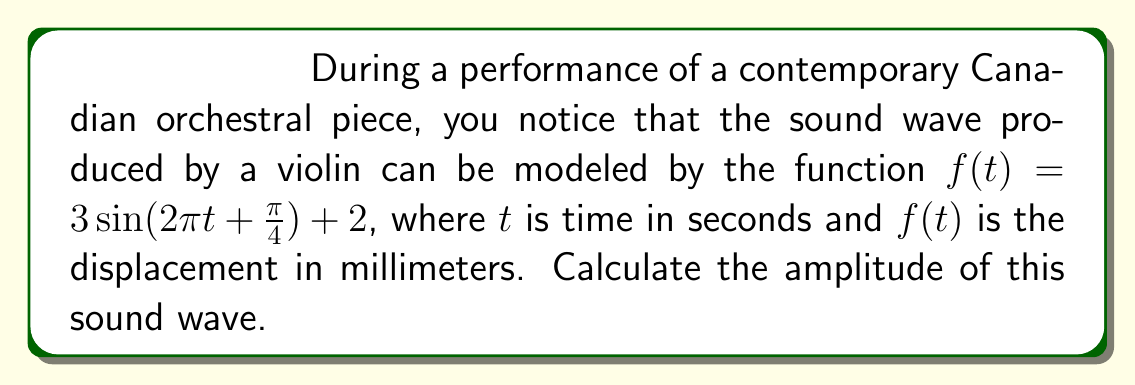Show me your answer to this math problem. To find the amplitude of the sound wave, we need to analyze the given function:

$f(t) = 3\sin(2\pi t + \frac{\pi}{4}) + 2$

1) The general form of a sine function is:
   $A\sin(Bt + C) + D$
   where $A$ is the amplitude, $B$ is the angular frequency, $C$ is the phase shift, and $D$ is the vertical shift.

2) In our function:
   $A = 3$
   $B = 2\pi$
   $C = \frac{\pi}{4}$
   $D = 2$

3) The amplitude is the absolute value of $A$, which is the coefficient of the sine function.

4) Therefore, the amplitude of this sound wave is 3 millimeters.

Note: The vertical shift ($D = 2$) does not affect the amplitude. It only moves the entire wave up or down on the coordinate plane.
Answer: 3 mm 